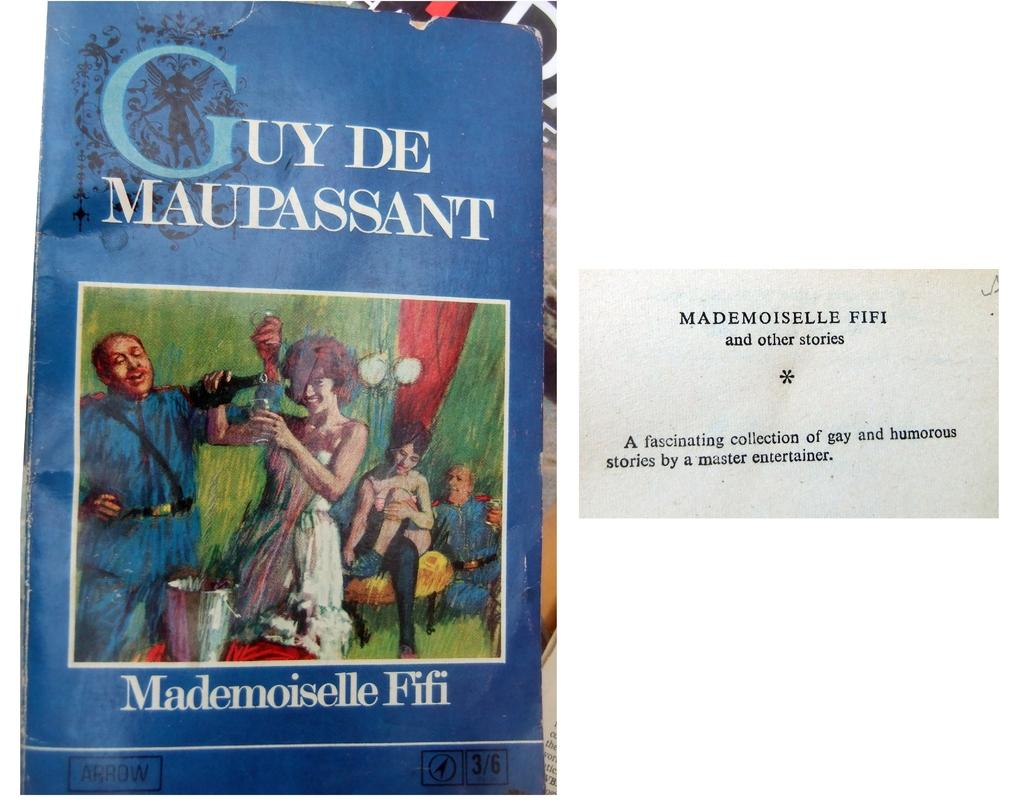<image>
Provide a brief description of the given image. A book by Mademoiselle Fifi has a blue cover with people on it. 